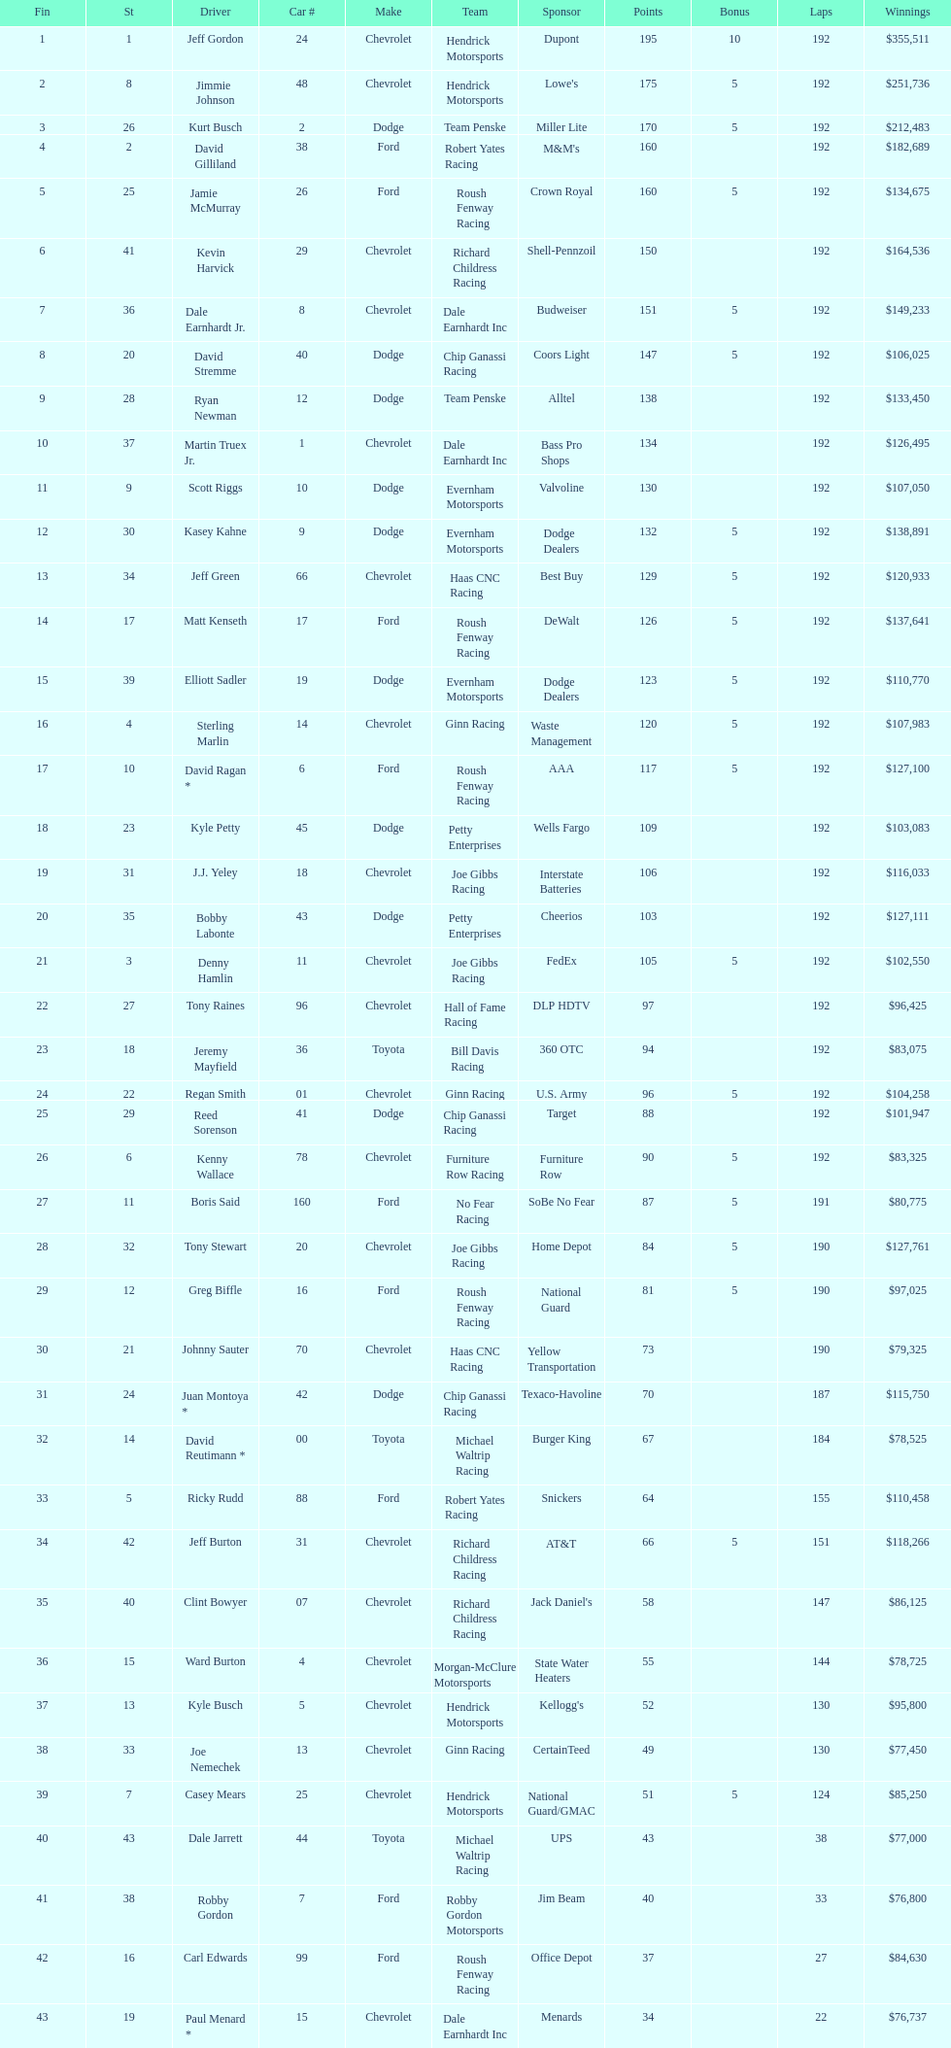What driver earned the least amount of winnings? Paul Menard *. 